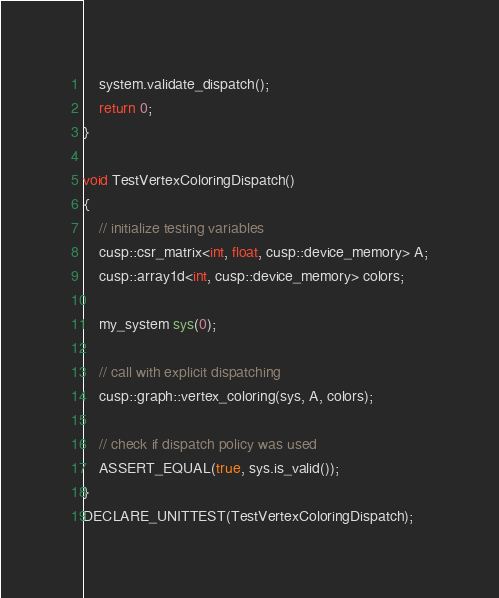<code> <loc_0><loc_0><loc_500><loc_500><_Cuda_>    system.validate_dispatch();
    return 0;
}

void TestVertexColoringDispatch()
{
    // initialize testing variables
    cusp::csr_matrix<int, float, cusp::device_memory> A;
    cusp::array1d<int, cusp::device_memory> colors;

    my_system sys(0);

    // call with explicit dispatching
    cusp::graph::vertex_coloring(sys, A, colors);

    // check if dispatch policy was used
    ASSERT_EQUAL(true, sys.is_valid());
}
DECLARE_UNITTEST(TestVertexColoringDispatch);

</code> 